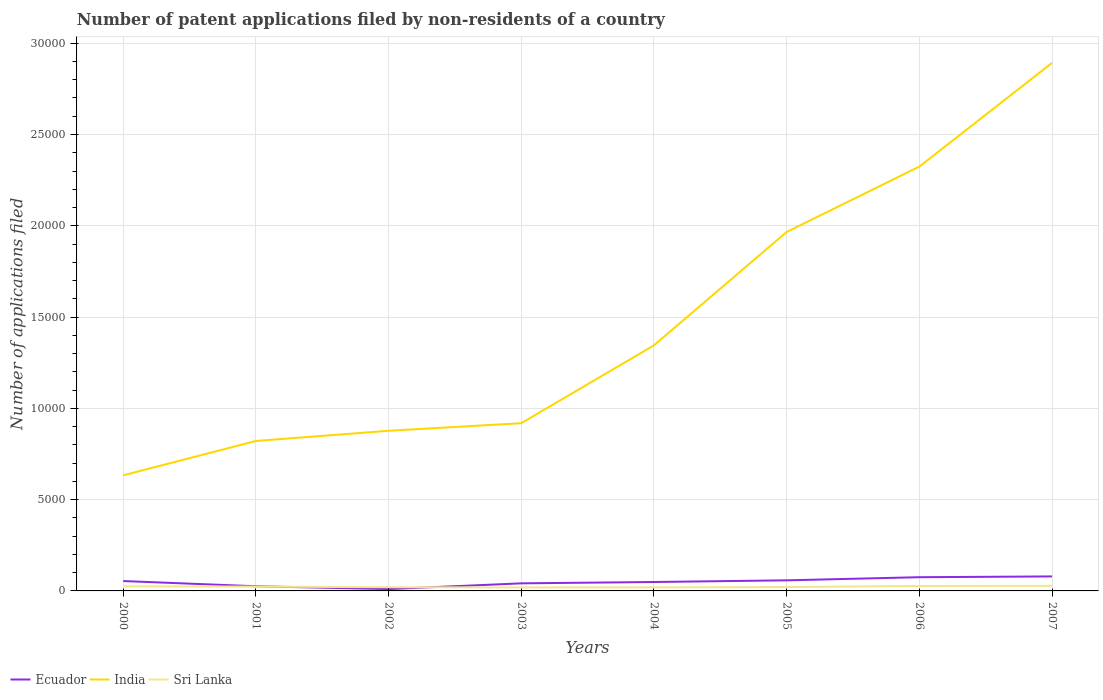How many different coloured lines are there?
Keep it short and to the point. 3. Across all years, what is the maximum number of applications filed in India?
Make the answer very short. 6332. What is the total number of applications filed in India in the graph?
Your response must be concise. -1.41e+04. What is the difference between the highest and the second highest number of applications filed in Ecuador?
Give a very brief answer. 693. What is the difference between the highest and the lowest number of applications filed in Sri Lanka?
Give a very brief answer. 4. How many years are there in the graph?
Make the answer very short. 8. Are the values on the major ticks of Y-axis written in scientific E-notation?
Provide a succinct answer. No. Does the graph contain any zero values?
Offer a very short reply. No. Does the graph contain grids?
Offer a very short reply. Yes. Where does the legend appear in the graph?
Provide a short and direct response. Bottom left. How many legend labels are there?
Offer a very short reply. 3. How are the legend labels stacked?
Offer a very short reply. Horizontal. What is the title of the graph?
Provide a short and direct response. Number of patent applications filed by non-residents of a country. What is the label or title of the Y-axis?
Provide a succinct answer. Number of applications filed. What is the Number of applications filed of Ecuador in 2000?
Provide a short and direct response. 541. What is the Number of applications filed of India in 2000?
Keep it short and to the point. 6332. What is the Number of applications filed in Sri Lanka in 2000?
Offer a terse response. 250. What is the Number of applications filed in Ecuador in 2001?
Offer a terse response. 256. What is the Number of applications filed of India in 2001?
Give a very brief answer. 8213. What is the Number of applications filed of Sri Lanka in 2001?
Provide a short and direct response. 236. What is the Number of applications filed in Ecuador in 2002?
Offer a very short reply. 101. What is the Number of applications filed in India in 2002?
Your response must be concise. 8772. What is the Number of applications filed in Sri Lanka in 2002?
Keep it short and to the point. 202. What is the Number of applications filed of Ecuador in 2003?
Give a very brief answer. 415. What is the Number of applications filed in India in 2003?
Offer a terse response. 9188. What is the Number of applications filed of Sri Lanka in 2003?
Provide a short and direct response. 189. What is the Number of applications filed in Ecuador in 2004?
Your answer should be very brief. 489. What is the Number of applications filed of India in 2004?
Your response must be concise. 1.35e+04. What is the Number of applications filed in Sri Lanka in 2004?
Your response must be concise. 195. What is the Number of applications filed in Ecuador in 2005?
Your answer should be compact. 580. What is the Number of applications filed in India in 2005?
Keep it short and to the point. 1.97e+04. What is the Number of applications filed in Sri Lanka in 2005?
Make the answer very short. 211. What is the Number of applications filed of Ecuador in 2006?
Offer a terse response. 751. What is the Number of applications filed of India in 2006?
Make the answer very short. 2.32e+04. What is the Number of applications filed of Sri Lanka in 2006?
Offer a terse response. 270. What is the Number of applications filed of Ecuador in 2007?
Keep it short and to the point. 794. What is the Number of applications filed of India in 2007?
Your answer should be compact. 2.89e+04. What is the Number of applications filed of Sri Lanka in 2007?
Your answer should be very brief. 279. Across all years, what is the maximum Number of applications filed of Ecuador?
Provide a succinct answer. 794. Across all years, what is the maximum Number of applications filed in India?
Your response must be concise. 2.89e+04. Across all years, what is the maximum Number of applications filed in Sri Lanka?
Your answer should be very brief. 279. Across all years, what is the minimum Number of applications filed of Ecuador?
Give a very brief answer. 101. Across all years, what is the minimum Number of applications filed of India?
Provide a short and direct response. 6332. Across all years, what is the minimum Number of applications filed of Sri Lanka?
Make the answer very short. 189. What is the total Number of applications filed of Ecuador in the graph?
Your response must be concise. 3927. What is the total Number of applications filed of India in the graph?
Keep it short and to the point. 1.18e+05. What is the total Number of applications filed in Sri Lanka in the graph?
Ensure brevity in your answer.  1832. What is the difference between the Number of applications filed in Ecuador in 2000 and that in 2001?
Ensure brevity in your answer.  285. What is the difference between the Number of applications filed in India in 2000 and that in 2001?
Keep it short and to the point. -1881. What is the difference between the Number of applications filed in Ecuador in 2000 and that in 2002?
Your answer should be compact. 440. What is the difference between the Number of applications filed in India in 2000 and that in 2002?
Your response must be concise. -2440. What is the difference between the Number of applications filed of Sri Lanka in 2000 and that in 2002?
Make the answer very short. 48. What is the difference between the Number of applications filed of Ecuador in 2000 and that in 2003?
Ensure brevity in your answer.  126. What is the difference between the Number of applications filed of India in 2000 and that in 2003?
Provide a short and direct response. -2856. What is the difference between the Number of applications filed in Sri Lanka in 2000 and that in 2003?
Ensure brevity in your answer.  61. What is the difference between the Number of applications filed of India in 2000 and that in 2004?
Offer a very short reply. -7120. What is the difference between the Number of applications filed of Sri Lanka in 2000 and that in 2004?
Keep it short and to the point. 55. What is the difference between the Number of applications filed of Ecuador in 2000 and that in 2005?
Provide a succinct answer. -39. What is the difference between the Number of applications filed of India in 2000 and that in 2005?
Your answer should be very brief. -1.33e+04. What is the difference between the Number of applications filed of Ecuador in 2000 and that in 2006?
Offer a terse response. -210. What is the difference between the Number of applications filed in India in 2000 and that in 2006?
Offer a very short reply. -1.69e+04. What is the difference between the Number of applications filed in Sri Lanka in 2000 and that in 2006?
Offer a terse response. -20. What is the difference between the Number of applications filed of Ecuador in 2000 and that in 2007?
Your answer should be very brief. -253. What is the difference between the Number of applications filed in India in 2000 and that in 2007?
Your answer should be very brief. -2.26e+04. What is the difference between the Number of applications filed of Ecuador in 2001 and that in 2002?
Provide a short and direct response. 155. What is the difference between the Number of applications filed of India in 2001 and that in 2002?
Your answer should be very brief. -559. What is the difference between the Number of applications filed of Ecuador in 2001 and that in 2003?
Keep it short and to the point. -159. What is the difference between the Number of applications filed in India in 2001 and that in 2003?
Your response must be concise. -975. What is the difference between the Number of applications filed in Sri Lanka in 2001 and that in 2003?
Ensure brevity in your answer.  47. What is the difference between the Number of applications filed of Ecuador in 2001 and that in 2004?
Your answer should be very brief. -233. What is the difference between the Number of applications filed in India in 2001 and that in 2004?
Give a very brief answer. -5239. What is the difference between the Number of applications filed of Ecuador in 2001 and that in 2005?
Offer a terse response. -324. What is the difference between the Number of applications filed in India in 2001 and that in 2005?
Ensure brevity in your answer.  -1.14e+04. What is the difference between the Number of applications filed in Sri Lanka in 2001 and that in 2005?
Your response must be concise. 25. What is the difference between the Number of applications filed in Ecuador in 2001 and that in 2006?
Your answer should be very brief. -495. What is the difference between the Number of applications filed in India in 2001 and that in 2006?
Ensure brevity in your answer.  -1.50e+04. What is the difference between the Number of applications filed in Sri Lanka in 2001 and that in 2006?
Your response must be concise. -34. What is the difference between the Number of applications filed of Ecuador in 2001 and that in 2007?
Keep it short and to the point. -538. What is the difference between the Number of applications filed in India in 2001 and that in 2007?
Keep it short and to the point. -2.07e+04. What is the difference between the Number of applications filed of Sri Lanka in 2001 and that in 2007?
Offer a terse response. -43. What is the difference between the Number of applications filed of Ecuador in 2002 and that in 2003?
Your answer should be compact. -314. What is the difference between the Number of applications filed in India in 2002 and that in 2003?
Offer a very short reply. -416. What is the difference between the Number of applications filed of Sri Lanka in 2002 and that in 2003?
Offer a terse response. 13. What is the difference between the Number of applications filed of Ecuador in 2002 and that in 2004?
Give a very brief answer. -388. What is the difference between the Number of applications filed of India in 2002 and that in 2004?
Offer a very short reply. -4680. What is the difference between the Number of applications filed of Sri Lanka in 2002 and that in 2004?
Make the answer very short. 7. What is the difference between the Number of applications filed in Ecuador in 2002 and that in 2005?
Offer a very short reply. -479. What is the difference between the Number of applications filed of India in 2002 and that in 2005?
Give a very brief answer. -1.09e+04. What is the difference between the Number of applications filed in Sri Lanka in 2002 and that in 2005?
Make the answer very short. -9. What is the difference between the Number of applications filed in Ecuador in 2002 and that in 2006?
Provide a short and direct response. -650. What is the difference between the Number of applications filed of India in 2002 and that in 2006?
Keep it short and to the point. -1.45e+04. What is the difference between the Number of applications filed in Sri Lanka in 2002 and that in 2006?
Ensure brevity in your answer.  -68. What is the difference between the Number of applications filed of Ecuador in 2002 and that in 2007?
Ensure brevity in your answer.  -693. What is the difference between the Number of applications filed in India in 2002 and that in 2007?
Provide a succinct answer. -2.02e+04. What is the difference between the Number of applications filed in Sri Lanka in 2002 and that in 2007?
Make the answer very short. -77. What is the difference between the Number of applications filed of Ecuador in 2003 and that in 2004?
Provide a short and direct response. -74. What is the difference between the Number of applications filed of India in 2003 and that in 2004?
Offer a very short reply. -4264. What is the difference between the Number of applications filed of Ecuador in 2003 and that in 2005?
Your response must be concise. -165. What is the difference between the Number of applications filed in India in 2003 and that in 2005?
Your answer should be very brief. -1.05e+04. What is the difference between the Number of applications filed in Sri Lanka in 2003 and that in 2005?
Provide a succinct answer. -22. What is the difference between the Number of applications filed in Ecuador in 2003 and that in 2006?
Provide a succinct answer. -336. What is the difference between the Number of applications filed in India in 2003 and that in 2006?
Keep it short and to the point. -1.41e+04. What is the difference between the Number of applications filed of Sri Lanka in 2003 and that in 2006?
Offer a very short reply. -81. What is the difference between the Number of applications filed of Ecuador in 2003 and that in 2007?
Make the answer very short. -379. What is the difference between the Number of applications filed of India in 2003 and that in 2007?
Provide a succinct answer. -1.97e+04. What is the difference between the Number of applications filed of Sri Lanka in 2003 and that in 2007?
Give a very brief answer. -90. What is the difference between the Number of applications filed in Ecuador in 2004 and that in 2005?
Keep it short and to the point. -91. What is the difference between the Number of applications filed in India in 2004 and that in 2005?
Your answer should be very brief. -6209. What is the difference between the Number of applications filed in Sri Lanka in 2004 and that in 2005?
Your response must be concise. -16. What is the difference between the Number of applications filed in Ecuador in 2004 and that in 2006?
Your answer should be very brief. -262. What is the difference between the Number of applications filed in India in 2004 and that in 2006?
Offer a very short reply. -9790. What is the difference between the Number of applications filed in Sri Lanka in 2004 and that in 2006?
Keep it short and to the point. -75. What is the difference between the Number of applications filed in Ecuador in 2004 and that in 2007?
Your response must be concise. -305. What is the difference between the Number of applications filed of India in 2004 and that in 2007?
Keep it short and to the point. -1.55e+04. What is the difference between the Number of applications filed of Sri Lanka in 2004 and that in 2007?
Make the answer very short. -84. What is the difference between the Number of applications filed of Ecuador in 2005 and that in 2006?
Offer a terse response. -171. What is the difference between the Number of applications filed of India in 2005 and that in 2006?
Provide a short and direct response. -3581. What is the difference between the Number of applications filed of Sri Lanka in 2005 and that in 2006?
Your response must be concise. -59. What is the difference between the Number of applications filed in Ecuador in 2005 and that in 2007?
Give a very brief answer. -214. What is the difference between the Number of applications filed in India in 2005 and that in 2007?
Your answer should be very brief. -9261. What is the difference between the Number of applications filed of Sri Lanka in 2005 and that in 2007?
Offer a terse response. -68. What is the difference between the Number of applications filed in Ecuador in 2006 and that in 2007?
Provide a short and direct response. -43. What is the difference between the Number of applications filed in India in 2006 and that in 2007?
Offer a very short reply. -5680. What is the difference between the Number of applications filed of Ecuador in 2000 and the Number of applications filed of India in 2001?
Provide a short and direct response. -7672. What is the difference between the Number of applications filed in Ecuador in 2000 and the Number of applications filed in Sri Lanka in 2001?
Your response must be concise. 305. What is the difference between the Number of applications filed of India in 2000 and the Number of applications filed of Sri Lanka in 2001?
Your answer should be very brief. 6096. What is the difference between the Number of applications filed of Ecuador in 2000 and the Number of applications filed of India in 2002?
Make the answer very short. -8231. What is the difference between the Number of applications filed in Ecuador in 2000 and the Number of applications filed in Sri Lanka in 2002?
Offer a very short reply. 339. What is the difference between the Number of applications filed of India in 2000 and the Number of applications filed of Sri Lanka in 2002?
Keep it short and to the point. 6130. What is the difference between the Number of applications filed in Ecuador in 2000 and the Number of applications filed in India in 2003?
Your answer should be compact. -8647. What is the difference between the Number of applications filed of Ecuador in 2000 and the Number of applications filed of Sri Lanka in 2003?
Your answer should be very brief. 352. What is the difference between the Number of applications filed of India in 2000 and the Number of applications filed of Sri Lanka in 2003?
Your response must be concise. 6143. What is the difference between the Number of applications filed in Ecuador in 2000 and the Number of applications filed in India in 2004?
Ensure brevity in your answer.  -1.29e+04. What is the difference between the Number of applications filed in Ecuador in 2000 and the Number of applications filed in Sri Lanka in 2004?
Keep it short and to the point. 346. What is the difference between the Number of applications filed in India in 2000 and the Number of applications filed in Sri Lanka in 2004?
Ensure brevity in your answer.  6137. What is the difference between the Number of applications filed in Ecuador in 2000 and the Number of applications filed in India in 2005?
Ensure brevity in your answer.  -1.91e+04. What is the difference between the Number of applications filed of Ecuador in 2000 and the Number of applications filed of Sri Lanka in 2005?
Keep it short and to the point. 330. What is the difference between the Number of applications filed in India in 2000 and the Number of applications filed in Sri Lanka in 2005?
Provide a succinct answer. 6121. What is the difference between the Number of applications filed of Ecuador in 2000 and the Number of applications filed of India in 2006?
Provide a succinct answer. -2.27e+04. What is the difference between the Number of applications filed of Ecuador in 2000 and the Number of applications filed of Sri Lanka in 2006?
Make the answer very short. 271. What is the difference between the Number of applications filed in India in 2000 and the Number of applications filed in Sri Lanka in 2006?
Offer a terse response. 6062. What is the difference between the Number of applications filed of Ecuador in 2000 and the Number of applications filed of India in 2007?
Ensure brevity in your answer.  -2.84e+04. What is the difference between the Number of applications filed of Ecuador in 2000 and the Number of applications filed of Sri Lanka in 2007?
Provide a succinct answer. 262. What is the difference between the Number of applications filed in India in 2000 and the Number of applications filed in Sri Lanka in 2007?
Provide a short and direct response. 6053. What is the difference between the Number of applications filed of Ecuador in 2001 and the Number of applications filed of India in 2002?
Ensure brevity in your answer.  -8516. What is the difference between the Number of applications filed in India in 2001 and the Number of applications filed in Sri Lanka in 2002?
Make the answer very short. 8011. What is the difference between the Number of applications filed of Ecuador in 2001 and the Number of applications filed of India in 2003?
Ensure brevity in your answer.  -8932. What is the difference between the Number of applications filed of Ecuador in 2001 and the Number of applications filed of Sri Lanka in 2003?
Your answer should be compact. 67. What is the difference between the Number of applications filed in India in 2001 and the Number of applications filed in Sri Lanka in 2003?
Offer a terse response. 8024. What is the difference between the Number of applications filed of Ecuador in 2001 and the Number of applications filed of India in 2004?
Your answer should be compact. -1.32e+04. What is the difference between the Number of applications filed of India in 2001 and the Number of applications filed of Sri Lanka in 2004?
Your response must be concise. 8018. What is the difference between the Number of applications filed of Ecuador in 2001 and the Number of applications filed of India in 2005?
Your answer should be compact. -1.94e+04. What is the difference between the Number of applications filed of India in 2001 and the Number of applications filed of Sri Lanka in 2005?
Your response must be concise. 8002. What is the difference between the Number of applications filed of Ecuador in 2001 and the Number of applications filed of India in 2006?
Make the answer very short. -2.30e+04. What is the difference between the Number of applications filed of India in 2001 and the Number of applications filed of Sri Lanka in 2006?
Your answer should be very brief. 7943. What is the difference between the Number of applications filed of Ecuador in 2001 and the Number of applications filed of India in 2007?
Your response must be concise. -2.87e+04. What is the difference between the Number of applications filed of India in 2001 and the Number of applications filed of Sri Lanka in 2007?
Your answer should be compact. 7934. What is the difference between the Number of applications filed of Ecuador in 2002 and the Number of applications filed of India in 2003?
Keep it short and to the point. -9087. What is the difference between the Number of applications filed of Ecuador in 2002 and the Number of applications filed of Sri Lanka in 2003?
Ensure brevity in your answer.  -88. What is the difference between the Number of applications filed in India in 2002 and the Number of applications filed in Sri Lanka in 2003?
Your response must be concise. 8583. What is the difference between the Number of applications filed of Ecuador in 2002 and the Number of applications filed of India in 2004?
Provide a succinct answer. -1.34e+04. What is the difference between the Number of applications filed of Ecuador in 2002 and the Number of applications filed of Sri Lanka in 2004?
Provide a succinct answer. -94. What is the difference between the Number of applications filed in India in 2002 and the Number of applications filed in Sri Lanka in 2004?
Offer a very short reply. 8577. What is the difference between the Number of applications filed of Ecuador in 2002 and the Number of applications filed of India in 2005?
Offer a very short reply. -1.96e+04. What is the difference between the Number of applications filed of Ecuador in 2002 and the Number of applications filed of Sri Lanka in 2005?
Your answer should be compact. -110. What is the difference between the Number of applications filed of India in 2002 and the Number of applications filed of Sri Lanka in 2005?
Your answer should be compact. 8561. What is the difference between the Number of applications filed of Ecuador in 2002 and the Number of applications filed of India in 2006?
Ensure brevity in your answer.  -2.31e+04. What is the difference between the Number of applications filed in Ecuador in 2002 and the Number of applications filed in Sri Lanka in 2006?
Your response must be concise. -169. What is the difference between the Number of applications filed in India in 2002 and the Number of applications filed in Sri Lanka in 2006?
Provide a short and direct response. 8502. What is the difference between the Number of applications filed of Ecuador in 2002 and the Number of applications filed of India in 2007?
Your answer should be very brief. -2.88e+04. What is the difference between the Number of applications filed in Ecuador in 2002 and the Number of applications filed in Sri Lanka in 2007?
Offer a very short reply. -178. What is the difference between the Number of applications filed of India in 2002 and the Number of applications filed of Sri Lanka in 2007?
Provide a succinct answer. 8493. What is the difference between the Number of applications filed of Ecuador in 2003 and the Number of applications filed of India in 2004?
Offer a terse response. -1.30e+04. What is the difference between the Number of applications filed of Ecuador in 2003 and the Number of applications filed of Sri Lanka in 2004?
Offer a very short reply. 220. What is the difference between the Number of applications filed of India in 2003 and the Number of applications filed of Sri Lanka in 2004?
Offer a very short reply. 8993. What is the difference between the Number of applications filed in Ecuador in 2003 and the Number of applications filed in India in 2005?
Make the answer very short. -1.92e+04. What is the difference between the Number of applications filed of Ecuador in 2003 and the Number of applications filed of Sri Lanka in 2005?
Your response must be concise. 204. What is the difference between the Number of applications filed of India in 2003 and the Number of applications filed of Sri Lanka in 2005?
Your answer should be compact. 8977. What is the difference between the Number of applications filed in Ecuador in 2003 and the Number of applications filed in India in 2006?
Your response must be concise. -2.28e+04. What is the difference between the Number of applications filed in Ecuador in 2003 and the Number of applications filed in Sri Lanka in 2006?
Your answer should be compact. 145. What is the difference between the Number of applications filed in India in 2003 and the Number of applications filed in Sri Lanka in 2006?
Give a very brief answer. 8918. What is the difference between the Number of applications filed in Ecuador in 2003 and the Number of applications filed in India in 2007?
Ensure brevity in your answer.  -2.85e+04. What is the difference between the Number of applications filed of Ecuador in 2003 and the Number of applications filed of Sri Lanka in 2007?
Ensure brevity in your answer.  136. What is the difference between the Number of applications filed of India in 2003 and the Number of applications filed of Sri Lanka in 2007?
Your response must be concise. 8909. What is the difference between the Number of applications filed in Ecuador in 2004 and the Number of applications filed in India in 2005?
Your answer should be very brief. -1.92e+04. What is the difference between the Number of applications filed in Ecuador in 2004 and the Number of applications filed in Sri Lanka in 2005?
Provide a succinct answer. 278. What is the difference between the Number of applications filed in India in 2004 and the Number of applications filed in Sri Lanka in 2005?
Provide a succinct answer. 1.32e+04. What is the difference between the Number of applications filed of Ecuador in 2004 and the Number of applications filed of India in 2006?
Give a very brief answer. -2.28e+04. What is the difference between the Number of applications filed of Ecuador in 2004 and the Number of applications filed of Sri Lanka in 2006?
Your response must be concise. 219. What is the difference between the Number of applications filed in India in 2004 and the Number of applications filed in Sri Lanka in 2006?
Give a very brief answer. 1.32e+04. What is the difference between the Number of applications filed of Ecuador in 2004 and the Number of applications filed of India in 2007?
Give a very brief answer. -2.84e+04. What is the difference between the Number of applications filed of Ecuador in 2004 and the Number of applications filed of Sri Lanka in 2007?
Ensure brevity in your answer.  210. What is the difference between the Number of applications filed in India in 2004 and the Number of applications filed in Sri Lanka in 2007?
Provide a short and direct response. 1.32e+04. What is the difference between the Number of applications filed in Ecuador in 2005 and the Number of applications filed in India in 2006?
Make the answer very short. -2.27e+04. What is the difference between the Number of applications filed of Ecuador in 2005 and the Number of applications filed of Sri Lanka in 2006?
Offer a terse response. 310. What is the difference between the Number of applications filed in India in 2005 and the Number of applications filed in Sri Lanka in 2006?
Your answer should be very brief. 1.94e+04. What is the difference between the Number of applications filed in Ecuador in 2005 and the Number of applications filed in India in 2007?
Make the answer very short. -2.83e+04. What is the difference between the Number of applications filed in Ecuador in 2005 and the Number of applications filed in Sri Lanka in 2007?
Make the answer very short. 301. What is the difference between the Number of applications filed of India in 2005 and the Number of applications filed of Sri Lanka in 2007?
Your response must be concise. 1.94e+04. What is the difference between the Number of applications filed in Ecuador in 2006 and the Number of applications filed in India in 2007?
Give a very brief answer. -2.82e+04. What is the difference between the Number of applications filed of Ecuador in 2006 and the Number of applications filed of Sri Lanka in 2007?
Keep it short and to the point. 472. What is the difference between the Number of applications filed in India in 2006 and the Number of applications filed in Sri Lanka in 2007?
Provide a succinct answer. 2.30e+04. What is the average Number of applications filed of Ecuador per year?
Your response must be concise. 490.88. What is the average Number of applications filed of India per year?
Provide a short and direct response. 1.47e+04. What is the average Number of applications filed in Sri Lanka per year?
Give a very brief answer. 229. In the year 2000, what is the difference between the Number of applications filed in Ecuador and Number of applications filed in India?
Ensure brevity in your answer.  -5791. In the year 2000, what is the difference between the Number of applications filed in Ecuador and Number of applications filed in Sri Lanka?
Your answer should be very brief. 291. In the year 2000, what is the difference between the Number of applications filed in India and Number of applications filed in Sri Lanka?
Your answer should be very brief. 6082. In the year 2001, what is the difference between the Number of applications filed of Ecuador and Number of applications filed of India?
Offer a terse response. -7957. In the year 2001, what is the difference between the Number of applications filed of India and Number of applications filed of Sri Lanka?
Keep it short and to the point. 7977. In the year 2002, what is the difference between the Number of applications filed in Ecuador and Number of applications filed in India?
Your answer should be very brief. -8671. In the year 2002, what is the difference between the Number of applications filed in Ecuador and Number of applications filed in Sri Lanka?
Offer a terse response. -101. In the year 2002, what is the difference between the Number of applications filed of India and Number of applications filed of Sri Lanka?
Provide a succinct answer. 8570. In the year 2003, what is the difference between the Number of applications filed of Ecuador and Number of applications filed of India?
Offer a terse response. -8773. In the year 2003, what is the difference between the Number of applications filed of Ecuador and Number of applications filed of Sri Lanka?
Ensure brevity in your answer.  226. In the year 2003, what is the difference between the Number of applications filed in India and Number of applications filed in Sri Lanka?
Provide a succinct answer. 8999. In the year 2004, what is the difference between the Number of applications filed in Ecuador and Number of applications filed in India?
Make the answer very short. -1.30e+04. In the year 2004, what is the difference between the Number of applications filed of Ecuador and Number of applications filed of Sri Lanka?
Provide a succinct answer. 294. In the year 2004, what is the difference between the Number of applications filed of India and Number of applications filed of Sri Lanka?
Provide a short and direct response. 1.33e+04. In the year 2005, what is the difference between the Number of applications filed of Ecuador and Number of applications filed of India?
Your answer should be very brief. -1.91e+04. In the year 2005, what is the difference between the Number of applications filed of Ecuador and Number of applications filed of Sri Lanka?
Your answer should be very brief. 369. In the year 2005, what is the difference between the Number of applications filed of India and Number of applications filed of Sri Lanka?
Offer a very short reply. 1.94e+04. In the year 2006, what is the difference between the Number of applications filed in Ecuador and Number of applications filed in India?
Give a very brief answer. -2.25e+04. In the year 2006, what is the difference between the Number of applications filed of Ecuador and Number of applications filed of Sri Lanka?
Provide a short and direct response. 481. In the year 2006, what is the difference between the Number of applications filed in India and Number of applications filed in Sri Lanka?
Make the answer very short. 2.30e+04. In the year 2007, what is the difference between the Number of applications filed in Ecuador and Number of applications filed in India?
Provide a short and direct response. -2.81e+04. In the year 2007, what is the difference between the Number of applications filed of Ecuador and Number of applications filed of Sri Lanka?
Provide a short and direct response. 515. In the year 2007, what is the difference between the Number of applications filed of India and Number of applications filed of Sri Lanka?
Your response must be concise. 2.86e+04. What is the ratio of the Number of applications filed of Ecuador in 2000 to that in 2001?
Ensure brevity in your answer.  2.11. What is the ratio of the Number of applications filed in India in 2000 to that in 2001?
Offer a terse response. 0.77. What is the ratio of the Number of applications filed in Sri Lanka in 2000 to that in 2001?
Your response must be concise. 1.06. What is the ratio of the Number of applications filed of Ecuador in 2000 to that in 2002?
Your answer should be compact. 5.36. What is the ratio of the Number of applications filed in India in 2000 to that in 2002?
Keep it short and to the point. 0.72. What is the ratio of the Number of applications filed in Sri Lanka in 2000 to that in 2002?
Provide a short and direct response. 1.24. What is the ratio of the Number of applications filed of Ecuador in 2000 to that in 2003?
Your answer should be compact. 1.3. What is the ratio of the Number of applications filed in India in 2000 to that in 2003?
Offer a very short reply. 0.69. What is the ratio of the Number of applications filed of Sri Lanka in 2000 to that in 2003?
Your response must be concise. 1.32. What is the ratio of the Number of applications filed in Ecuador in 2000 to that in 2004?
Keep it short and to the point. 1.11. What is the ratio of the Number of applications filed of India in 2000 to that in 2004?
Give a very brief answer. 0.47. What is the ratio of the Number of applications filed of Sri Lanka in 2000 to that in 2004?
Give a very brief answer. 1.28. What is the ratio of the Number of applications filed of Ecuador in 2000 to that in 2005?
Your response must be concise. 0.93. What is the ratio of the Number of applications filed of India in 2000 to that in 2005?
Give a very brief answer. 0.32. What is the ratio of the Number of applications filed of Sri Lanka in 2000 to that in 2005?
Your response must be concise. 1.18. What is the ratio of the Number of applications filed of Ecuador in 2000 to that in 2006?
Provide a short and direct response. 0.72. What is the ratio of the Number of applications filed of India in 2000 to that in 2006?
Give a very brief answer. 0.27. What is the ratio of the Number of applications filed in Sri Lanka in 2000 to that in 2006?
Offer a very short reply. 0.93. What is the ratio of the Number of applications filed of Ecuador in 2000 to that in 2007?
Offer a very short reply. 0.68. What is the ratio of the Number of applications filed in India in 2000 to that in 2007?
Your answer should be very brief. 0.22. What is the ratio of the Number of applications filed of Sri Lanka in 2000 to that in 2007?
Your answer should be very brief. 0.9. What is the ratio of the Number of applications filed of Ecuador in 2001 to that in 2002?
Keep it short and to the point. 2.53. What is the ratio of the Number of applications filed in India in 2001 to that in 2002?
Your response must be concise. 0.94. What is the ratio of the Number of applications filed of Sri Lanka in 2001 to that in 2002?
Provide a succinct answer. 1.17. What is the ratio of the Number of applications filed in Ecuador in 2001 to that in 2003?
Offer a terse response. 0.62. What is the ratio of the Number of applications filed of India in 2001 to that in 2003?
Provide a short and direct response. 0.89. What is the ratio of the Number of applications filed of Sri Lanka in 2001 to that in 2003?
Make the answer very short. 1.25. What is the ratio of the Number of applications filed in Ecuador in 2001 to that in 2004?
Make the answer very short. 0.52. What is the ratio of the Number of applications filed in India in 2001 to that in 2004?
Offer a terse response. 0.61. What is the ratio of the Number of applications filed of Sri Lanka in 2001 to that in 2004?
Offer a terse response. 1.21. What is the ratio of the Number of applications filed in Ecuador in 2001 to that in 2005?
Your answer should be compact. 0.44. What is the ratio of the Number of applications filed of India in 2001 to that in 2005?
Your answer should be very brief. 0.42. What is the ratio of the Number of applications filed in Sri Lanka in 2001 to that in 2005?
Keep it short and to the point. 1.12. What is the ratio of the Number of applications filed of Ecuador in 2001 to that in 2006?
Keep it short and to the point. 0.34. What is the ratio of the Number of applications filed of India in 2001 to that in 2006?
Your response must be concise. 0.35. What is the ratio of the Number of applications filed of Sri Lanka in 2001 to that in 2006?
Keep it short and to the point. 0.87. What is the ratio of the Number of applications filed in Ecuador in 2001 to that in 2007?
Ensure brevity in your answer.  0.32. What is the ratio of the Number of applications filed in India in 2001 to that in 2007?
Your answer should be very brief. 0.28. What is the ratio of the Number of applications filed of Sri Lanka in 2001 to that in 2007?
Offer a terse response. 0.85. What is the ratio of the Number of applications filed in Ecuador in 2002 to that in 2003?
Give a very brief answer. 0.24. What is the ratio of the Number of applications filed in India in 2002 to that in 2003?
Your answer should be compact. 0.95. What is the ratio of the Number of applications filed in Sri Lanka in 2002 to that in 2003?
Your answer should be compact. 1.07. What is the ratio of the Number of applications filed in Ecuador in 2002 to that in 2004?
Offer a terse response. 0.21. What is the ratio of the Number of applications filed of India in 2002 to that in 2004?
Give a very brief answer. 0.65. What is the ratio of the Number of applications filed in Sri Lanka in 2002 to that in 2004?
Give a very brief answer. 1.04. What is the ratio of the Number of applications filed of Ecuador in 2002 to that in 2005?
Your answer should be very brief. 0.17. What is the ratio of the Number of applications filed in India in 2002 to that in 2005?
Your answer should be very brief. 0.45. What is the ratio of the Number of applications filed of Sri Lanka in 2002 to that in 2005?
Your response must be concise. 0.96. What is the ratio of the Number of applications filed in Ecuador in 2002 to that in 2006?
Make the answer very short. 0.13. What is the ratio of the Number of applications filed of India in 2002 to that in 2006?
Give a very brief answer. 0.38. What is the ratio of the Number of applications filed in Sri Lanka in 2002 to that in 2006?
Give a very brief answer. 0.75. What is the ratio of the Number of applications filed in Ecuador in 2002 to that in 2007?
Your response must be concise. 0.13. What is the ratio of the Number of applications filed in India in 2002 to that in 2007?
Provide a short and direct response. 0.3. What is the ratio of the Number of applications filed of Sri Lanka in 2002 to that in 2007?
Your answer should be very brief. 0.72. What is the ratio of the Number of applications filed of Ecuador in 2003 to that in 2004?
Your answer should be very brief. 0.85. What is the ratio of the Number of applications filed of India in 2003 to that in 2004?
Your answer should be very brief. 0.68. What is the ratio of the Number of applications filed in Sri Lanka in 2003 to that in 2004?
Offer a very short reply. 0.97. What is the ratio of the Number of applications filed in Ecuador in 2003 to that in 2005?
Your response must be concise. 0.72. What is the ratio of the Number of applications filed in India in 2003 to that in 2005?
Offer a very short reply. 0.47. What is the ratio of the Number of applications filed of Sri Lanka in 2003 to that in 2005?
Provide a succinct answer. 0.9. What is the ratio of the Number of applications filed in Ecuador in 2003 to that in 2006?
Keep it short and to the point. 0.55. What is the ratio of the Number of applications filed in India in 2003 to that in 2006?
Offer a terse response. 0.4. What is the ratio of the Number of applications filed in Sri Lanka in 2003 to that in 2006?
Your answer should be compact. 0.7. What is the ratio of the Number of applications filed of Ecuador in 2003 to that in 2007?
Give a very brief answer. 0.52. What is the ratio of the Number of applications filed of India in 2003 to that in 2007?
Offer a terse response. 0.32. What is the ratio of the Number of applications filed in Sri Lanka in 2003 to that in 2007?
Provide a succinct answer. 0.68. What is the ratio of the Number of applications filed in Ecuador in 2004 to that in 2005?
Offer a very short reply. 0.84. What is the ratio of the Number of applications filed of India in 2004 to that in 2005?
Your answer should be very brief. 0.68. What is the ratio of the Number of applications filed of Sri Lanka in 2004 to that in 2005?
Make the answer very short. 0.92. What is the ratio of the Number of applications filed of Ecuador in 2004 to that in 2006?
Keep it short and to the point. 0.65. What is the ratio of the Number of applications filed of India in 2004 to that in 2006?
Give a very brief answer. 0.58. What is the ratio of the Number of applications filed of Sri Lanka in 2004 to that in 2006?
Provide a short and direct response. 0.72. What is the ratio of the Number of applications filed in Ecuador in 2004 to that in 2007?
Make the answer very short. 0.62. What is the ratio of the Number of applications filed of India in 2004 to that in 2007?
Your response must be concise. 0.47. What is the ratio of the Number of applications filed in Sri Lanka in 2004 to that in 2007?
Provide a short and direct response. 0.7. What is the ratio of the Number of applications filed of Ecuador in 2005 to that in 2006?
Keep it short and to the point. 0.77. What is the ratio of the Number of applications filed of India in 2005 to that in 2006?
Keep it short and to the point. 0.85. What is the ratio of the Number of applications filed in Sri Lanka in 2005 to that in 2006?
Make the answer very short. 0.78. What is the ratio of the Number of applications filed in Ecuador in 2005 to that in 2007?
Offer a very short reply. 0.73. What is the ratio of the Number of applications filed of India in 2005 to that in 2007?
Provide a succinct answer. 0.68. What is the ratio of the Number of applications filed in Sri Lanka in 2005 to that in 2007?
Offer a very short reply. 0.76. What is the ratio of the Number of applications filed of Ecuador in 2006 to that in 2007?
Your answer should be compact. 0.95. What is the ratio of the Number of applications filed of India in 2006 to that in 2007?
Offer a terse response. 0.8. What is the difference between the highest and the second highest Number of applications filed in India?
Your answer should be very brief. 5680. What is the difference between the highest and the lowest Number of applications filed in Ecuador?
Your response must be concise. 693. What is the difference between the highest and the lowest Number of applications filed in India?
Keep it short and to the point. 2.26e+04. What is the difference between the highest and the lowest Number of applications filed in Sri Lanka?
Your answer should be compact. 90. 